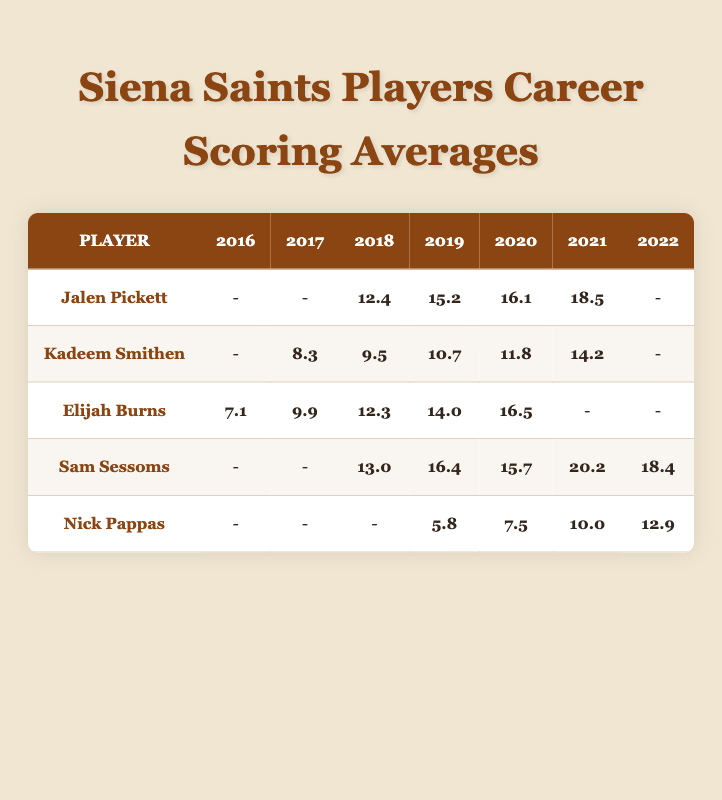What was Jalen Pickett's highest scoring average in a season? Looking at Jalen Pickett's row, the highest scoring average is found in the 2021 season with a score of 18.5.
Answer: 18.5 Which player had the lowest scoring average in 2021? In the 2021 column, I compare the scoring averages for each player. Nick Pappas had the lowest scoring average at 10.0.
Answer: 10.0 What is the scoring average increase for Elijah Burns from 2016 to 2020? To find the increase, subtract the 2016 score (7.1) from the 2020 score (16.5). The increase is 16.5 - 7.1 = 9.4.
Answer: 9.4 Did Kadeem Smithen's scoring average ever reach double digits? By reviewing Kadeem Smithen's row, I see that his scoring averages for 2018 (9.5), 2019 (10.7), 2020 (11.8), and 2021 (14.2) are all above 10, confirming that yes, he reached double digits.
Answer: Yes What is the average scoring average of Sam Sessoms over his career? To calculate the average, I sum up Sam Sessoms' scoring averages (13.0 + 16.4 + 15.7 + 20.2 + 18.4) which equals 83.7. Then I divide by the number of seasons, 5. Thus, 83.7 / 5 = 16.74.
Answer: 16.74 Which player improved their scoring average the most from one season to the next? On analyzing the table, Sam Sessoms improved from 15.7 in 2020 to 20.2 in 2021, an increase of 4.5. However, looking at Elijah Burns from 2019 to 2020, he improved from 14.0 to 16.5, an increase of 2.5. After checking all players, Sam Sessoms has the highest improvement.
Answer: Sam Sessoms How many seasons did Nick Pappas score below 10 points? Reviewing Nick Pappas' seasons, he scored below 10 only in the 2019 season (5.8) and 2020 season (7.5). Therefore, he had two seasons below 10.
Answer: 2 In which season did Elijah Burns have his highest average? Elijah Burns’ row shows his highest scoring average in 2020 with a score of 16.5.
Answer: 2020 Who scored the same average in 2018, and what was the score? Both Jalen Pickett and Sam Sessoms scored in 2018, with Jalen at 12.4 and Sam at 13.0; the player who scored the same average in 2018 is Elijah Burns with 12.3. So, nobody scored the same, as the nearest player recorded a different score.
Answer: None 